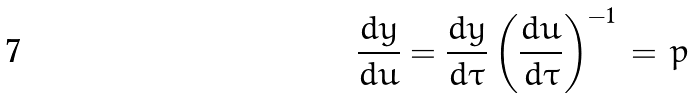Convert formula to latex. <formula><loc_0><loc_0><loc_500><loc_500>\frac { d y } { d u } = \frac { d y } { d \tau } \left ( \frac { d u } { d \tau } \right ) ^ { - 1 } \, = \, p</formula> 